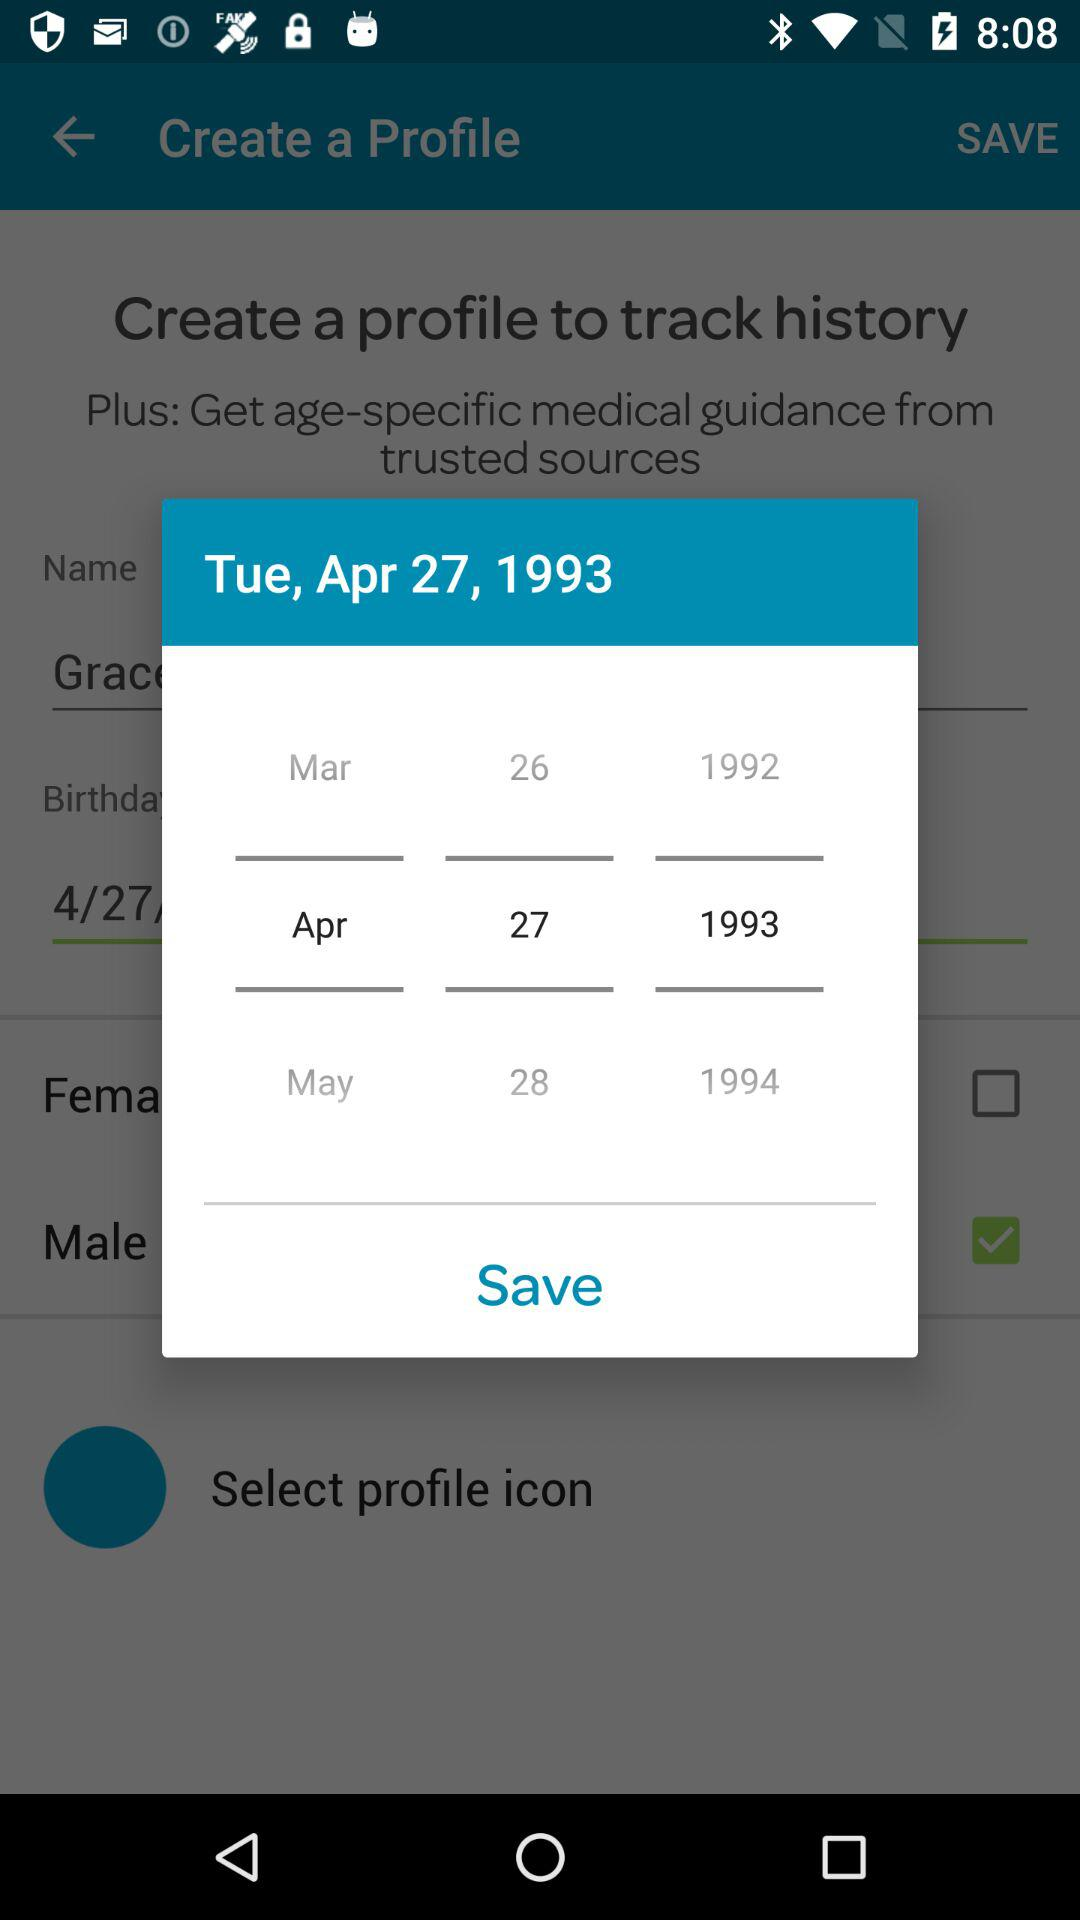How many years are represented in the date?
Answer the question using a single word or phrase. 3 